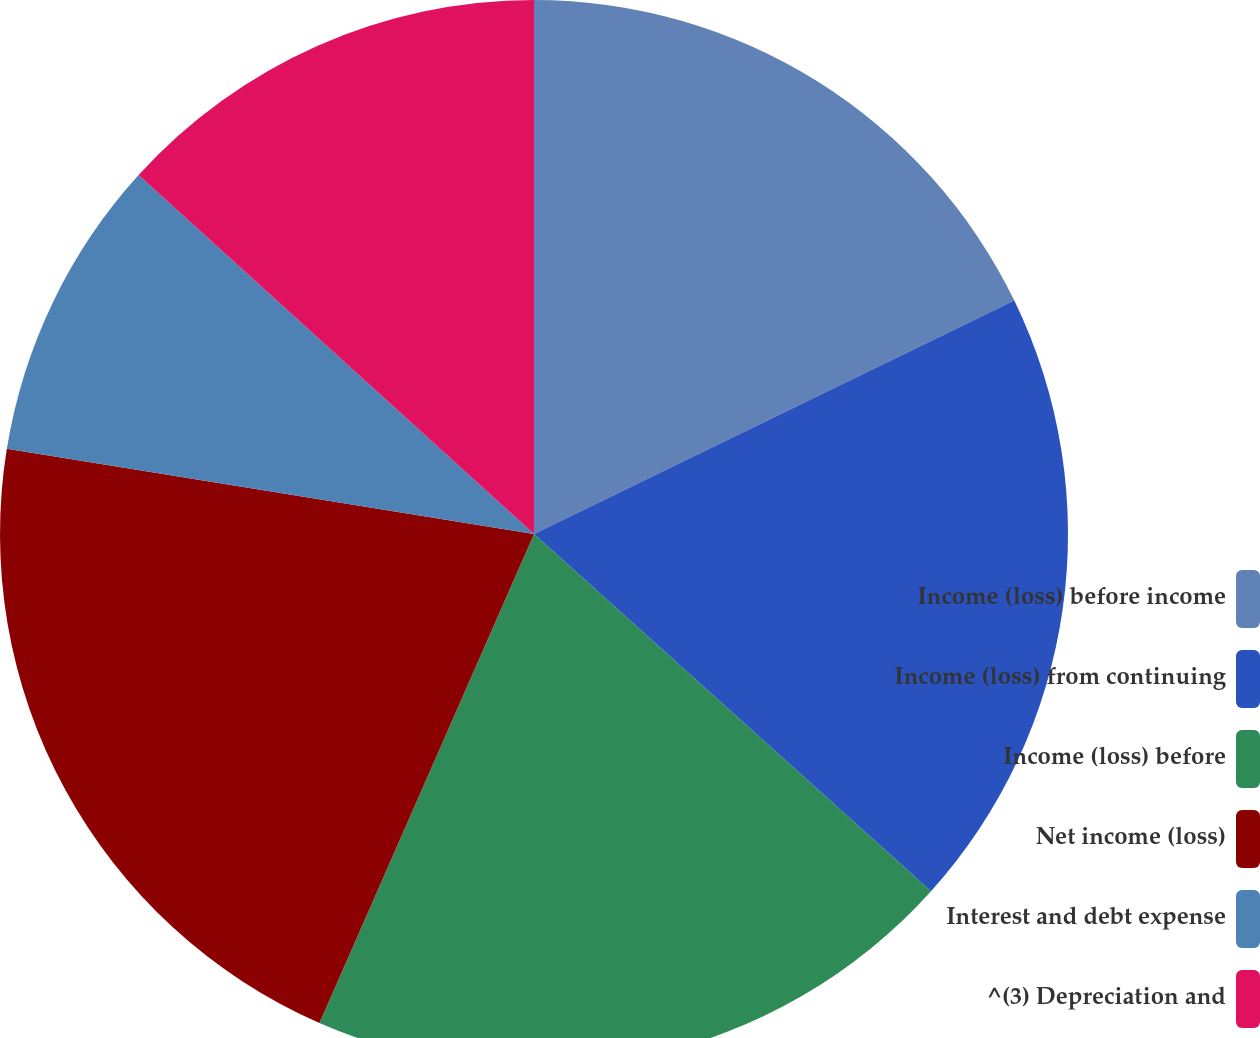Convert chart. <chart><loc_0><loc_0><loc_500><loc_500><pie_chart><fcel>Income (loss) before income<fcel>Income (loss) from continuing<fcel>Income (loss) before<fcel>Net income (loss)<fcel>Interest and debt expense<fcel>^(3) Depreciation and<nl><fcel>17.8%<fcel>18.86%<fcel>19.92%<fcel>20.97%<fcel>9.18%<fcel>13.27%<nl></chart> 